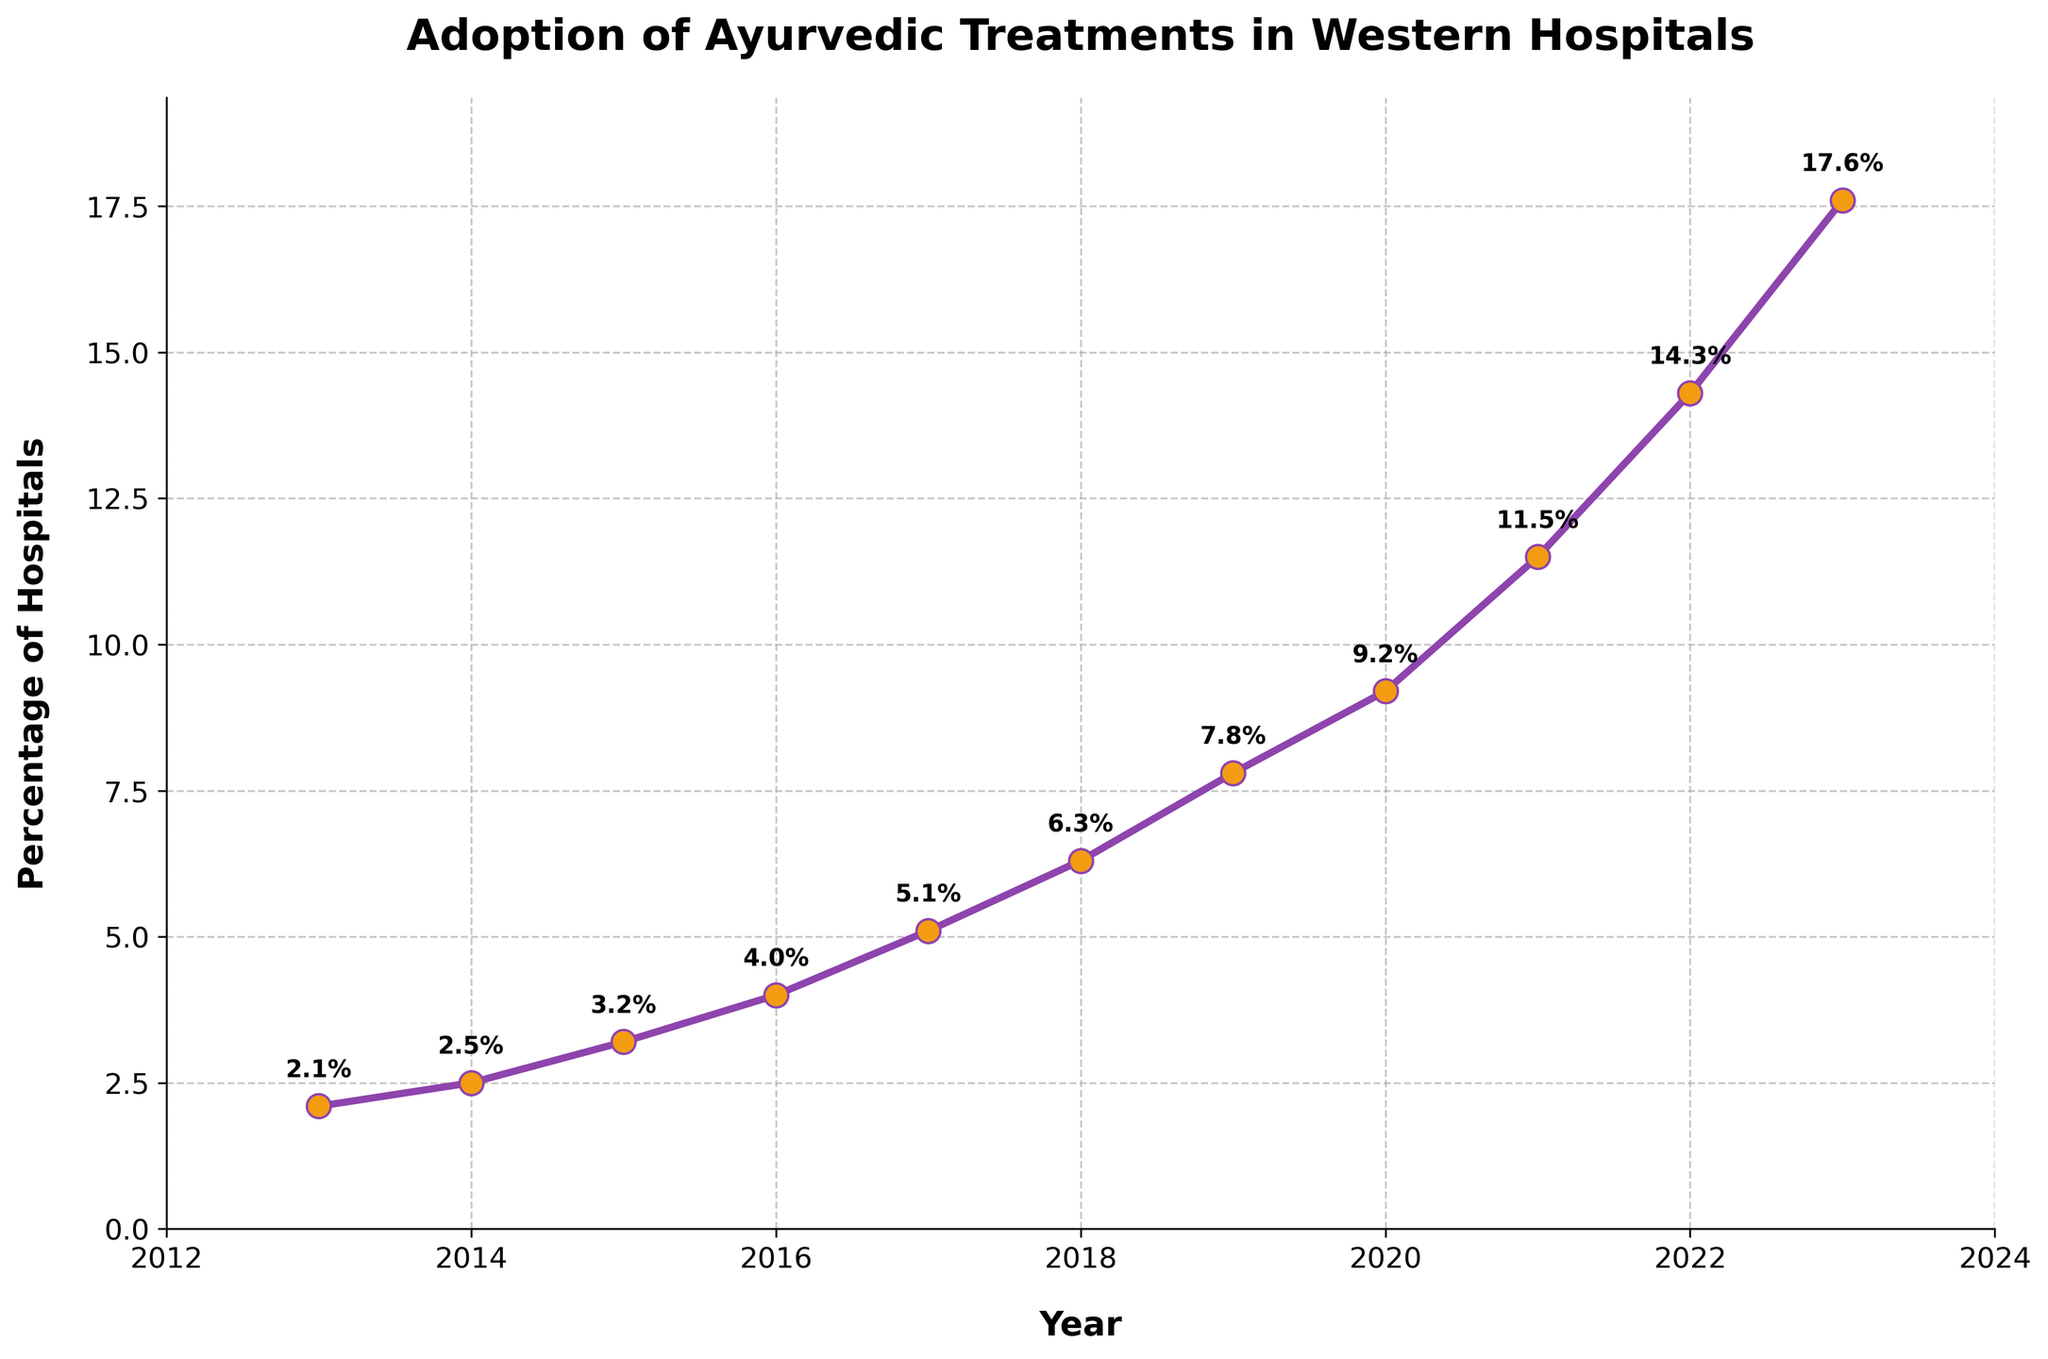What is the percentage increase in the adoption of Ayurvedic treatments from 2013 to 2023? Find the percentage values for 2013 and 2023, which are 2.1% and 17.6%, respectively. Subtract the 2013 value from the 2023 value (17.6 - 2.1) and you get 15.5%.
Answer: 15.5% What is the average percentage of hospitals adopting Ayurvedic treatments between 2015 and 2020? Identify the values from 2015 to 2020: 3.2, 4.0, 5.1, 6.3, 7.8, and 9.2. Add these values (3.2 + 4.0 + 5.1 + 6.3 + 7.8 + 9.2 = 35.6), then divide by the number of years (6). So, the average is 35.6 / 6.
Answer: 5.93 Between which two consecutive years was the largest increase in the percentage adoption of Ayurvedic treatments observed? Calculate the differences between consecutive years: 2014-2013 (0.4), 2015-2014 (0.7), 2016-2015 (0.8), 2017-2016 (1.1), 2018-2017 (1.2), 2019-2018 (1.5), 2020-2019 (1.4), 2021-2020 (2.3), 2022-2021 (2.8), 2023-2022 (3.3). The largest increase of 3.3% occurred between 2022 and 2023.
Answer: 2022 and 2023 What is the percentage of Western hospitals adopting Ayurvedic treatments in 2017? The value marked on the plot for the year 2017 is directly read from the figure, which is 5.1%.
Answer: 5.1% Was the adoption rate increase more than double from 2013 to 2021? Check the values for 2013 (2.1%) and 2021 (11.5%). To determine if 11.5% is more than double 2.1%, calculate 2.1 * 2 = 4.2. Since 11.5 > 4.2, the increase is more than double.
Answer: Yes By how much did the adoption rate increase each year on average over the decade? Sum up the increase rates for each year and then divide by the number of years (10). Increases: 0.4, 0.7, 0.8, 1.1, 1.2, 1.5, 1.4, 2.3, 2.8, 3.3. Sum: 15.5. The average increase is 15.5 / 10.
Answer: 1.55 